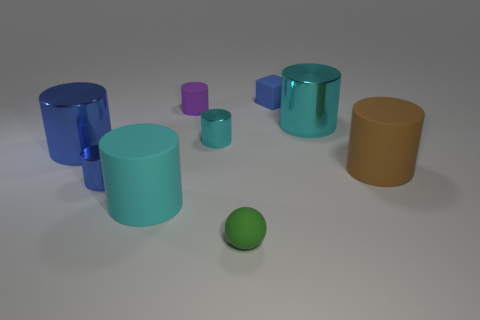Subtract all purple blocks. How many cyan cylinders are left? 3 Subtract 1 cylinders. How many cylinders are left? 6 Subtract all cyan cylinders. How many cylinders are left? 4 Subtract all blue cylinders. How many cylinders are left? 5 Subtract all purple cylinders. Subtract all gray spheres. How many cylinders are left? 6 Add 1 blue objects. How many objects exist? 10 Subtract all cubes. How many objects are left? 8 Add 4 cyan matte cylinders. How many cyan matte cylinders are left? 5 Add 1 small purple cylinders. How many small purple cylinders exist? 2 Subtract 0 purple balls. How many objects are left? 9 